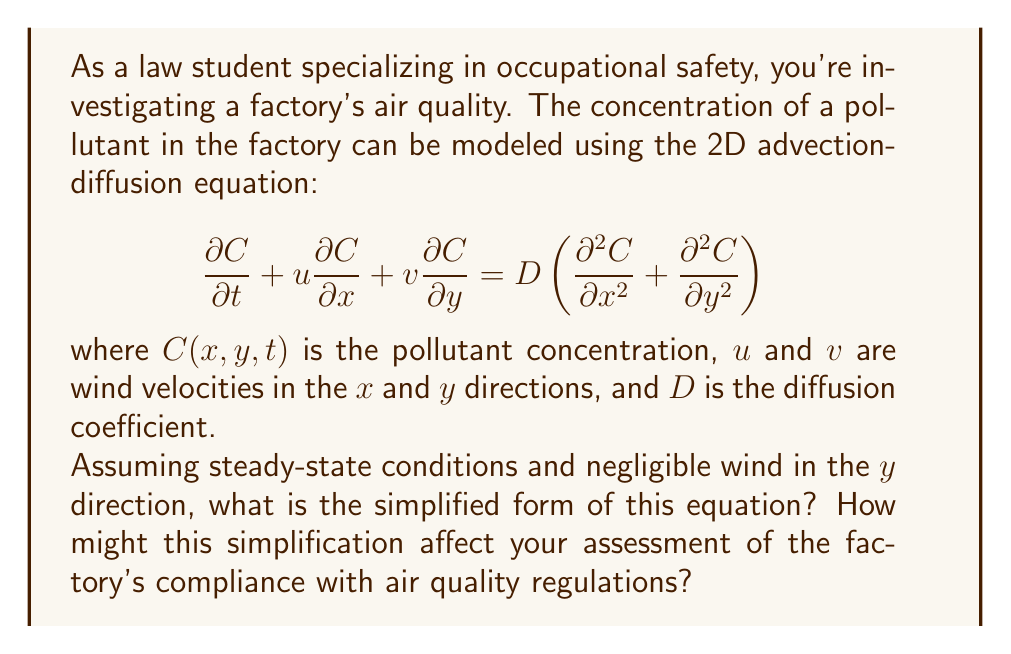Teach me how to tackle this problem. To simplify the equation, we'll follow these steps:

1) Steady-state conditions mean the concentration doesn't change with time, so:
   $$\frac{\partial C}{\partial t} = 0$$

2) Negligible wind in the $y$ direction means $v = 0$, so the term $v\frac{\partial C}{\partial y} = 0$

3) The original equation becomes:
   $$0 + u\frac{\partial C}{\partial x} + 0 = D\left(\frac{\partial^2 C}{\partial x^2} + \frac{\partial^2 C}{\partial y^2}\right)$$

4) Simplifying:
   $$u\frac{\partial C}{\partial x} = D\left(\frac{\partial^2 C}{\partial x^2} + \frac{\partial^2 C}{\partial y^2}\right)$$

This simplified equation describes how the pollutant concentration changes in space under steady-state conditions with wind blowing only in the $x$ direction.

From a legal perspective, this simplification could affect the assessment of factory compliance in several ways:

1) It assumes a constant pollutant emission, which may not reflect real-world variations in factory operations.
2) It doesn't account for vertical dispersion, potentially underestimating concentrations at certain heights.
3) The steady-state assumption might not capture short-term concentration spikes that could violate regulations.
4) Neglecting wind in the $y$ direction could lead to inaccurate predictions in more complex environments.

These limitations should be considered when using this model to assess compliance with air quality regulations.
Answer: $$u\frac{\partial C}{\partial x} = D\left(\frac{\partial^2 C}{\partial x^2} + \frac{\partial^2 C}{\partial y^2}\right)$$ 